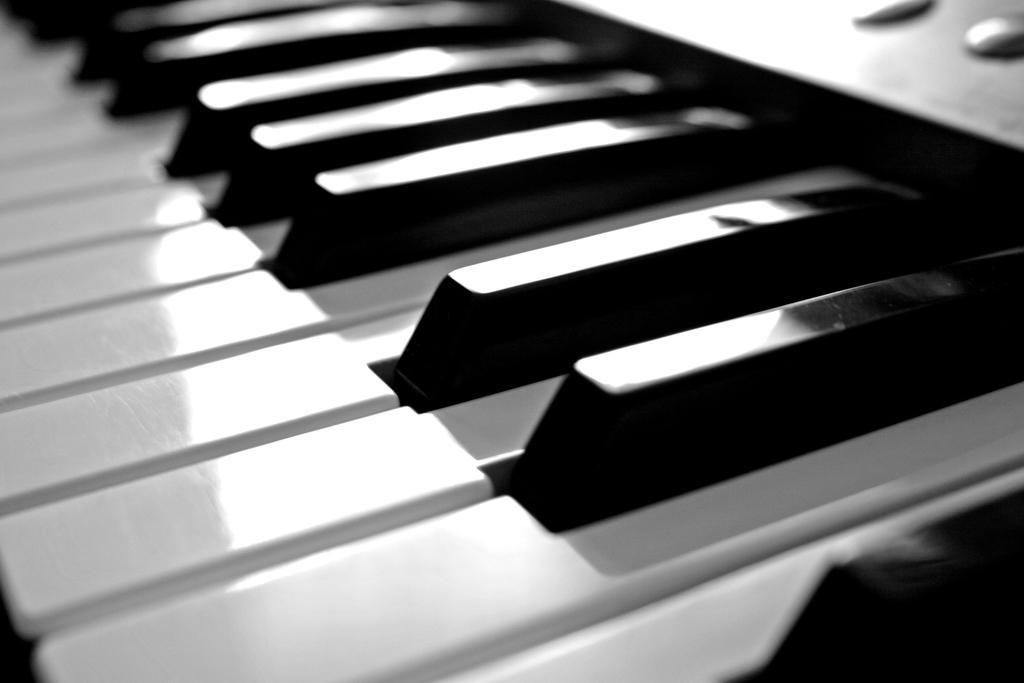In one or two sentences, can you explain what this image depicts? This is the picture of the piano keys in the piano. 